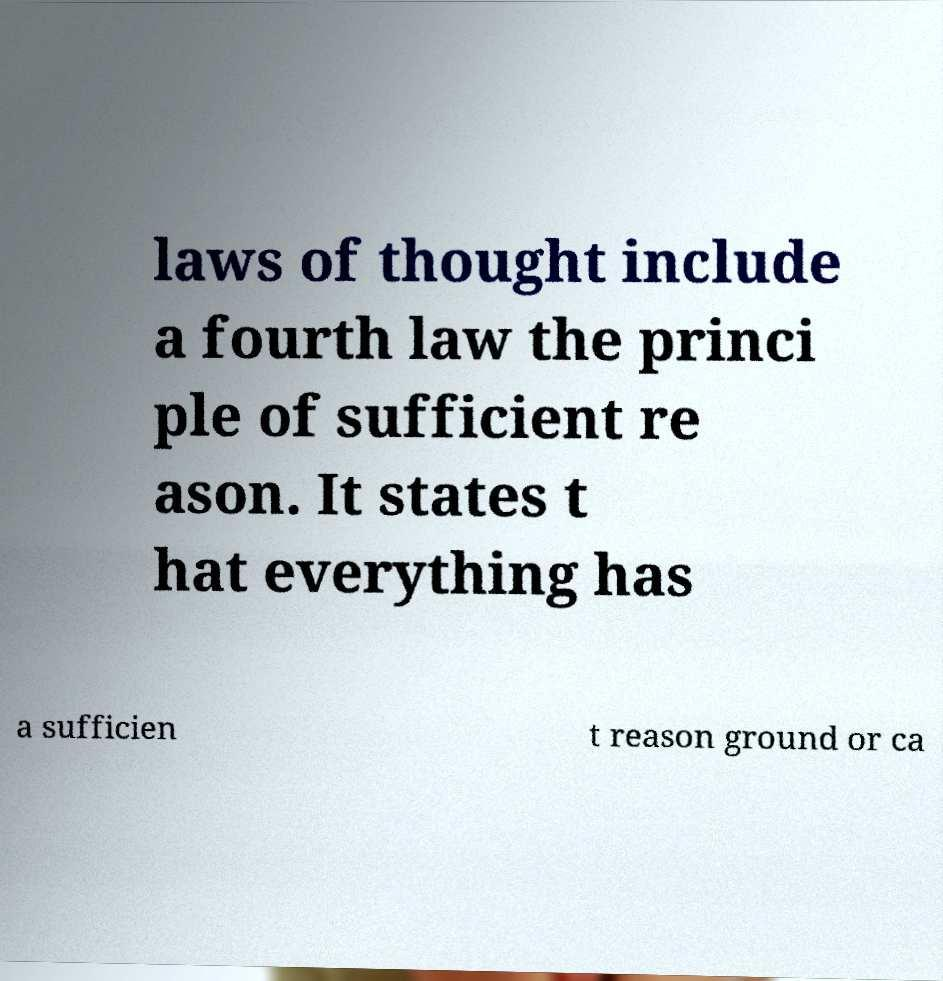For documentation purposes, I need the text within this image transcribed. Could you provide that? laws of thought include a fourth law the princi ple of sufficient re ason. It states t hat everything has a sufficien t reason ground or ca 